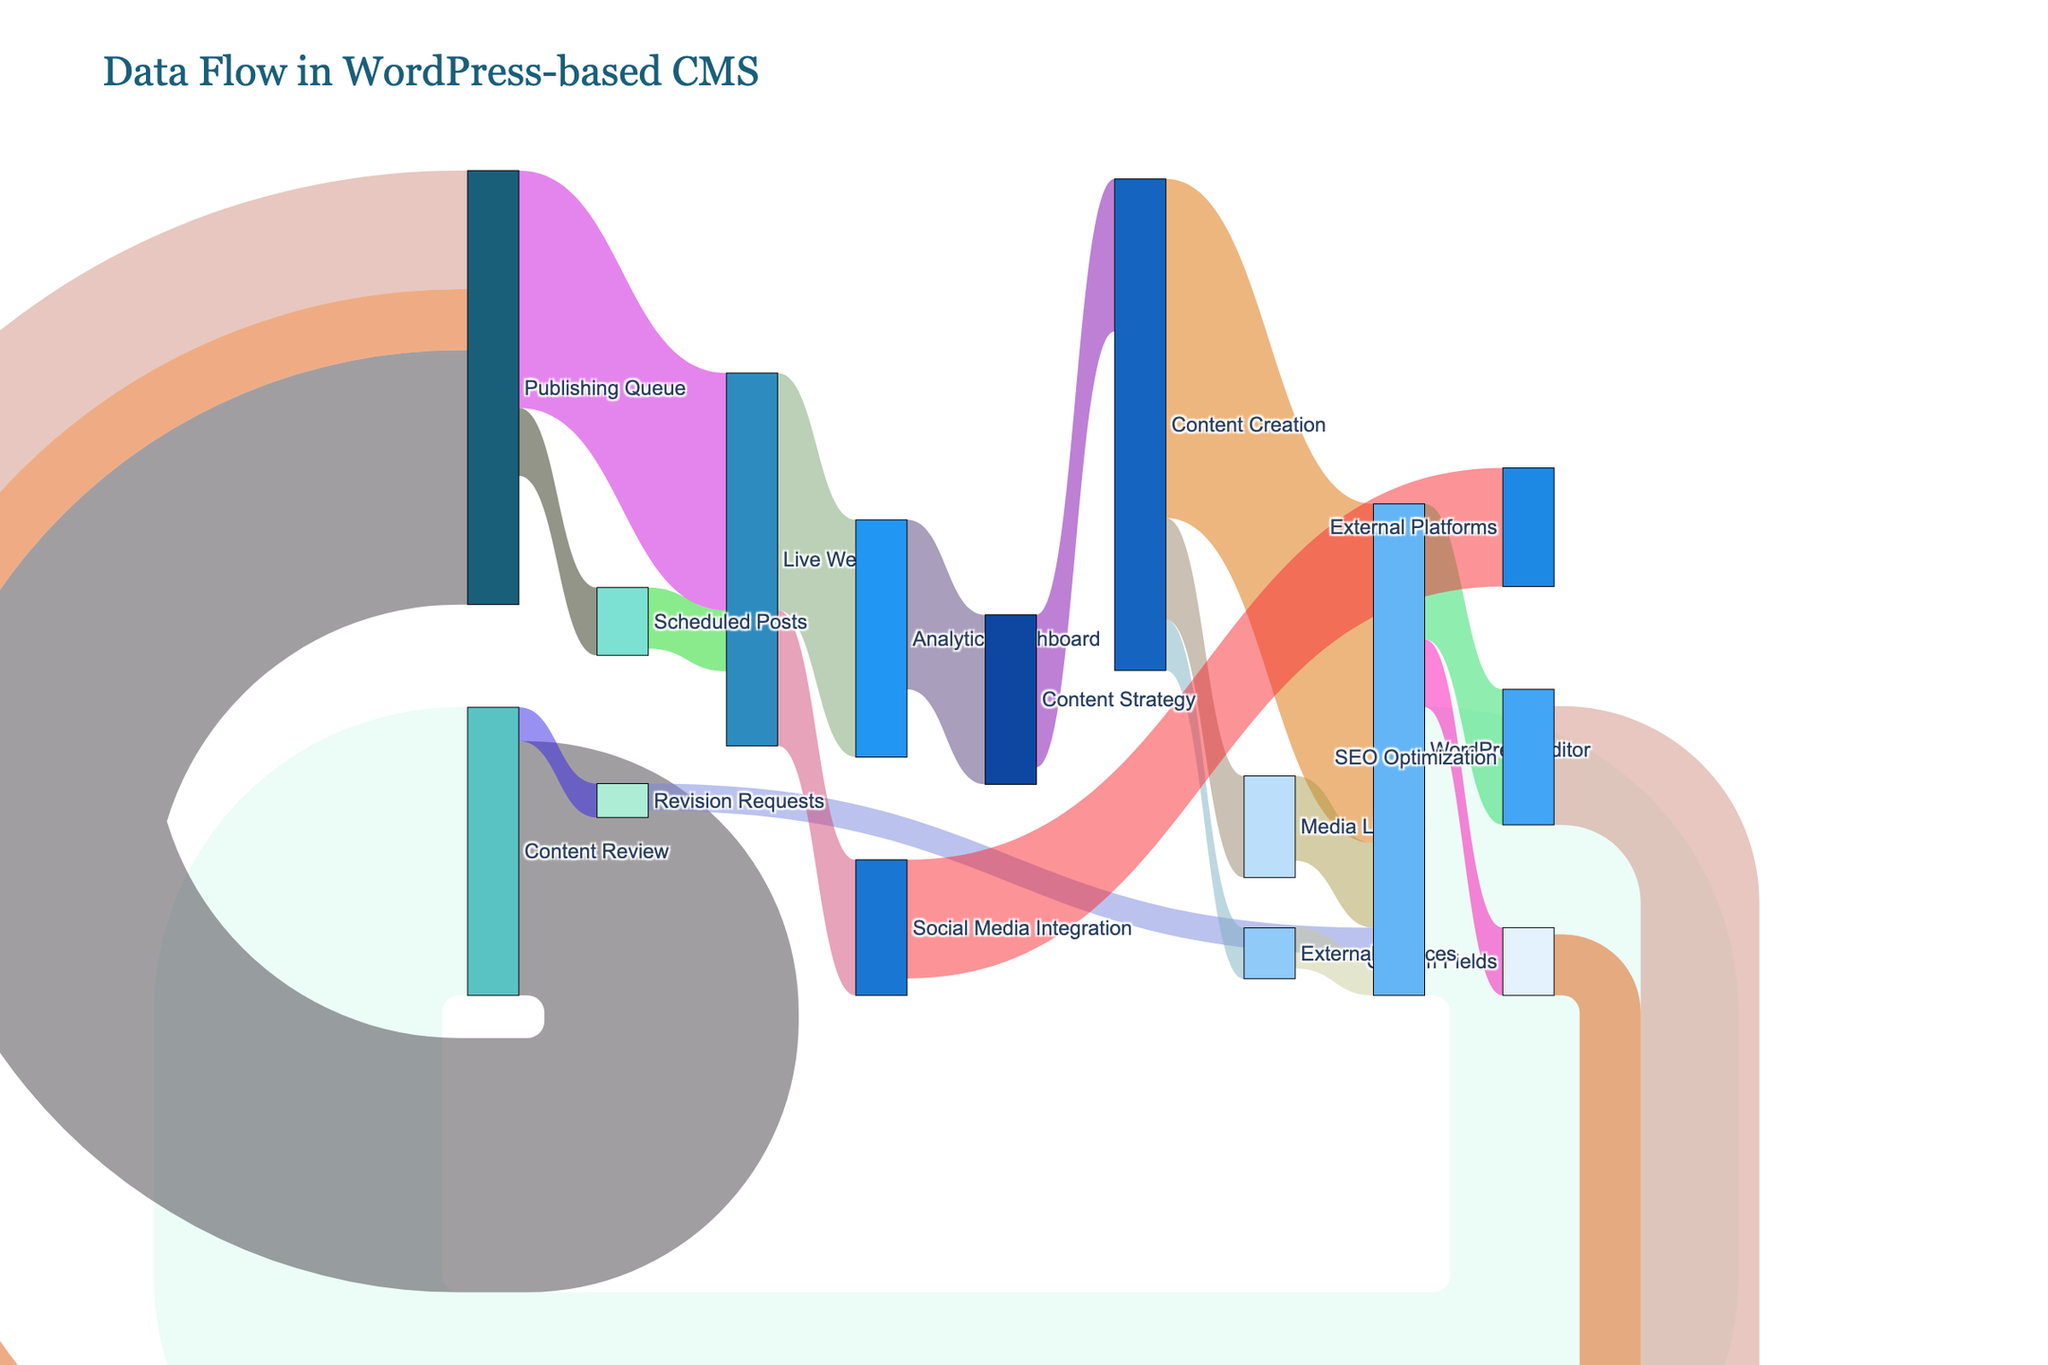What is the title of the figure? The title is displayed at the top of the diagram and typically summarizes the content or purpose of the figure.
Answer: Data Flow in WordPress-based CMS Which node has the highest number of outgoing connections? By looking at the nodes and counting the number of links going out from each node, we can determine which node has the highest number of outgoing connections. The "WordPress Editor" has connections to "Content Review," "SEO Optimization," "Custom Fields," and "Publishing Queue," as well as returning links from "Media Library" and "Revision Requests."
Answer: WordPress Editor How much content flows from "Publishing Queue" to "Live Website"? By finding the link between "Publishing Queue" and "Live Website," we can directly read the value associated with it. The link shows a value of 70.
Answer: 70 What is the total amount of content going into "WordPress Editor"? Sum the values of all links entering "WordPress Editor": from "Content Creation" (100) + "Media Library" (25) + "External Sources" (12) + "Revision Requests" (8). 100 + 25 + 12 + 8 = 145
Answer: 145 Compare the content value between "Content Creation" to "WordPress Editor" and "Content Creation" to "Media Library". Which one is higher? Compare the values of the links: "Content Creation" to "WordPress Editor" is 100 and "Content Creation" to "Media Library" is 30. 100 is greater than 30.
Answer: "Content Creation" to "WordPress Editor" What happens to the content after it is added to the "Media Library"? By following the links from "Media Library," we can see it goes to "WordPress Editor" with a value of 25.
Answer: It goes to "WordPress Editor." How many nodes are in the diagram? Count the unique entries in the combined list of 'source' and 'target' columns. The nodes listed are 19 in total.
Answer: 19 How does content flow from "SEO Optimization" to "Live Website"? The content from "SEO Optimization" goes to "Publishing Queue" with a value of 35, and then from "Publishing Queue" to "Live Website" with a value of 70. Therefore, the content flows SEO Optimization -> Publishing Queue -> Live Website.
Answer: Through "Publishing Queue." Which node has the smallest amount of content flow into it? By examining the incoming flow values for each node, "Revision Requests" has only 10 units of incoming content, receiving content exclusively from "Content Review."
Answer: Revision Requests What is the sum of content flowing out of "Live Website"? Sum the values of all links going out from "Live Website": "Analytics Dashboard" (70) + "Social Media Integration" (40). 70 + 40 = 110
Answer: 110 